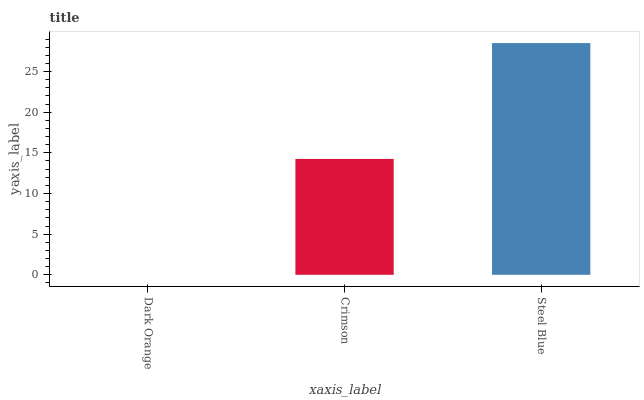Is Dark Orange the minimum?
Answer yes or no. Yes. Is Steel Blue the maximum?
Answer yes or no. Yes. Is Crimson the minimum?
Answer yes or no. No. Is Crimson the maximum?
Answer yes or no. No. Is Crimson greater than Dark Orange?
Answer yes or no. Yes. Is Dark Orange less than Crimson?
Answer yes or no. Yes. Is Dark Orange greater than Crimson?
Answer yes or no. No. Is Crimson less than Dark Orange?
Answer yes or no. No. Is Crimson the high median?
Answer yes or no. Yes. Is Crimson the low median?
Answer yes or no. Yes. Is Steel Blue the high median?
Answer yes or no. No. Is Dark Orange the low median?
Answer yes or no. No. 